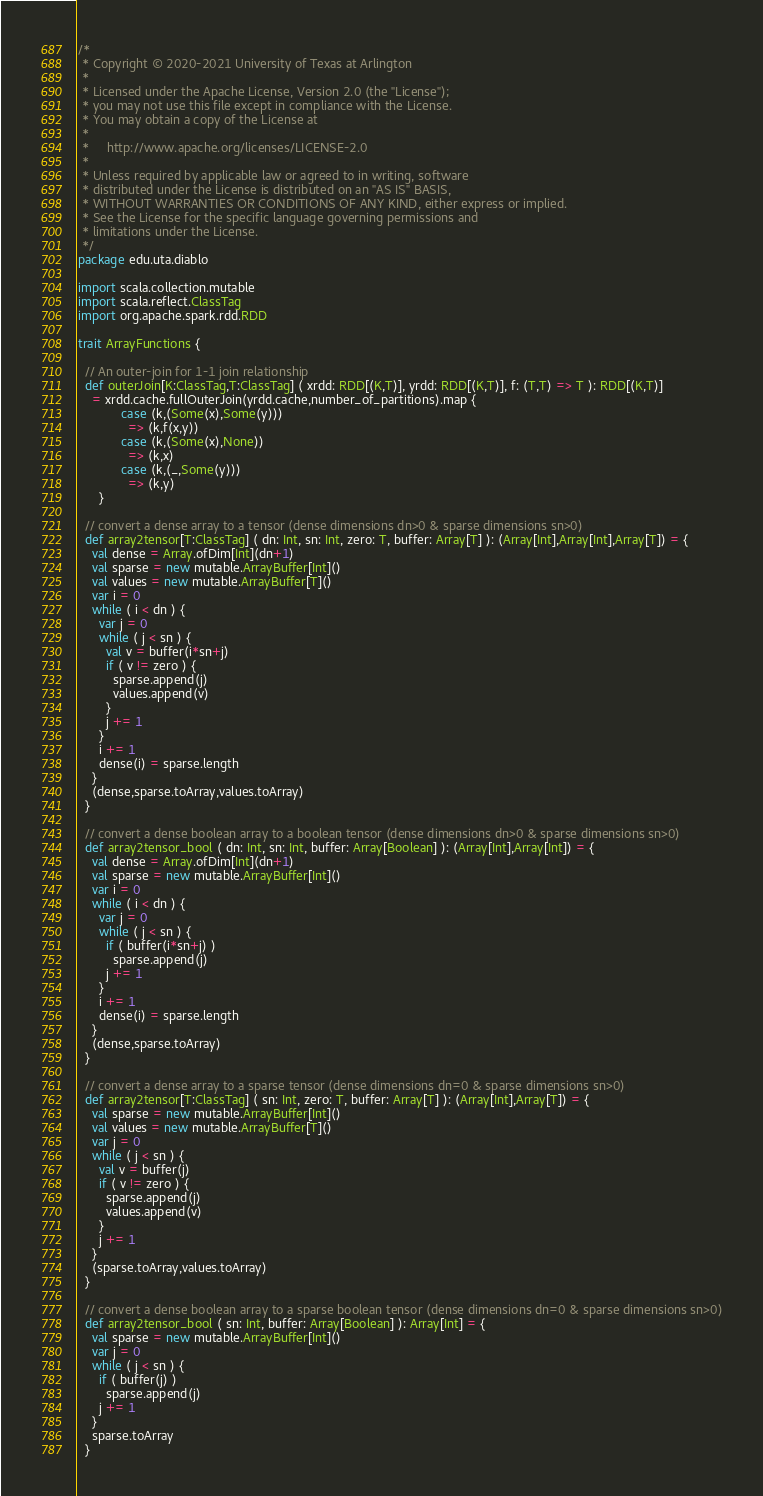<code> <loc_0><loc_0><loc_500><loc_500><_Scala_>/*
 * Copyright © 2020-2021 University of Texas at Arlington
 *
 * Licensed under the Apache License, Version 2.0 (the "License");
 * you may not use this file except in compliance with the License.
 * You may obtain a copy of the License at
 *
 *     http://www.apache.org/licenses/LICENSE-2.0
 *
 * Unless required by applicable law or agreed to in writing, software
 * distributed under the License is distributed on an "AS IS" BASIS,
 * WITHOUT WARRANTIES OR CONDITIONS OF ANY KIND, either express or implied.
 * See the License for the specific language governing permissions and
 * limitations under the License.
 */
package edu.uta.diablo

import scala.collection.mutable
import scala.reflect.ClassTag
import org.apache.spark.rdd.RDD

trait ArrayFunctions {

  // An outer-join for 1-1 join relationship
  def outerJoin[K:ClassTag,T:ClassTag] ( xrdd: RDD[(K,T)], yrdd: RDD[(K,T)], f: (T,T) => T ): RDD[(K,T)]
    = xrdd.cache.fullOuterJoin(yrdd.cache,number_of_partitions).map {
            case (k,(Some(x),Some(y)))
              => (k,f(x,y))
            case (k,(Some(x),None))
              => (k,x)
            case (k,(_,Some(y)))
              => (k,y)
      }

  // convert a dense array to a tensor (dense dimensions dn>0 & sparse dimensions sn>0)
  def array2tensor[T:ClassTag] ( dn: Int, sn: Int, zero: T, buffer: Array[T] ): (Array[Int],Array[Int],Array[T]) = {
    val dense = Array.ofDim[Int](dn+1)
    val sparse = new mutable.ArrayBuffer[Int]()
    val values = new mutable.ArrayBuffer[T]()
    var i = 0
    while ( i < dn ) {
      var j = 0
      while ( j < sn ) {
        val v = buffer(i*sn+j)
        if ( v != zero ) {
          sparse.append(j)
          values.append(v)
        }
        j += 1
      }
      i += 1
      dense(i) = sparse.length
    }
    (dense,sparse.toArray,values.toArray)
  }

  // convert a dense boolean array to a boolean tensor (dense dimensions dn>0 & sparse dimensions sn>0)
  def array2tensor_bool ( dn: Int, sn: Int, buffer: Array[Boolean] ): (Array[Int],Array[Int]) = {
    val dense = Array.ofDim[Int](dn+1)
    val sparse = new mutable.ArrayBuffer[Int]()
    var i = 0
    while ( i < dn ) {
      var j = 0
      while ( j < sn ) {
        if ( buffer(i*sn+j) )
          sparse.append(j)
        j += 1
      }
      i += 1
      dense(i) = sparse.length
    }
    (dense,sparse.toArray)
  }

  // convert a dense array to a sparse tensor (dense dimensions dn=0 & sparse dimensions sn>0)
  def array2tensor[T:ClassTag] ( sn: Int, zero: T, buffer: Array[T] ): (Array[Int],Array[T]) = {
    val sparse = new mutable.ArrayBuffer[Int]()
    val values = new mutable.ArrayBuffer[T]()
    var j = 0
    while ( j < sn ) {
      val v = buffer(j)
      if ( v != zero ) {
        sparse.append(j)
        values.append(v)
      }
      j += 1
    }
    (sparse.toArray,values.toArray)
  }

  // convert a dense boolean array to a sparse boolean tensor (dense dimensions dn=0 & sparse dimensions sn>0)
  def array2tensor_bool ( sn: Int, buffer: Array[Boolean] ): Array[Int] = {
    val sparse = new mutable.ArrayBuffer[Int]()
    var j = 0
    while ( j < sn ) {
      if ( buffer(j) )
        sparse.append(j)
      j += 1
    }
    sparse.toArray
  }
</code> 